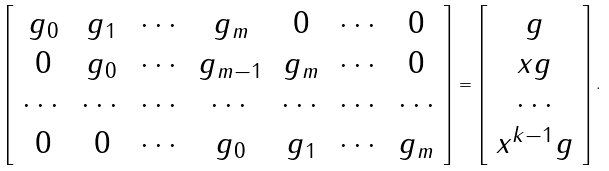<formula> <loc_0><loc_0><loc_500><loc_500>\left [ \begin{array} { c c c c c c c } g _ { 0 } & g _ { 1 } & \cdots & g _ { m } & 0 & \cdots & 0 \\ 0 & g _ { 0 } & \cdots & g _ { m - 1 } & g _ { m } & \cdots & 0 \\ \cdots & \cdots & \cdots & \cdots & \cdots & \cdots & \cdots \\ 0 & 0 & \cdots & g _ { 0 } & g _ { 1 } & \cdots & g _ { m } \\ \end{array} \right ] = \left [ \begin{array} { c } g \\ x g \\ \cdots \\ x ^ { k - 1 } g \\ \end{array} \right ] .</formula> 